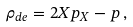<formula> <loc_0><loc_0><loc_500><loc_500>\rho _ { d e } = 2 X p _ { X } - p \, ,</formula> 